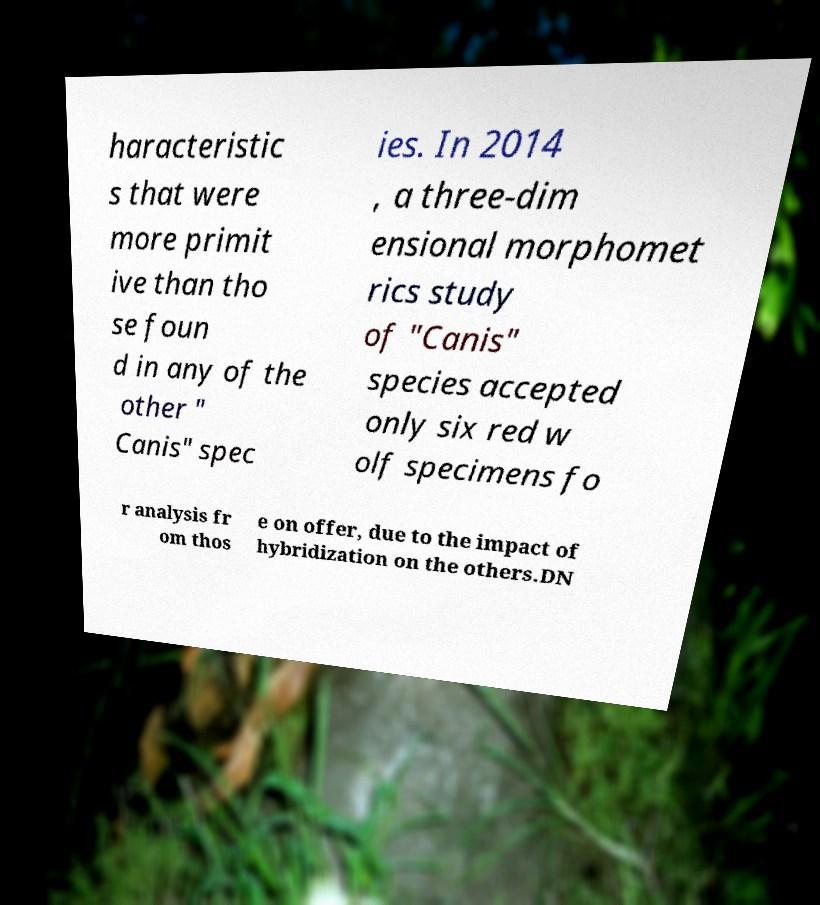Can you accurately transcribe the text from the provided image for me? haracteristic s that were more primit ive than tho se foun d in any of the other " Canis" spec ies. In 2014 , a three-dim ensional morphomet rics study of "Canis" species accepted only six red w olf specimens fo r analysis fr om thos e on offer, due to the impact of hybridization on the others.DN 